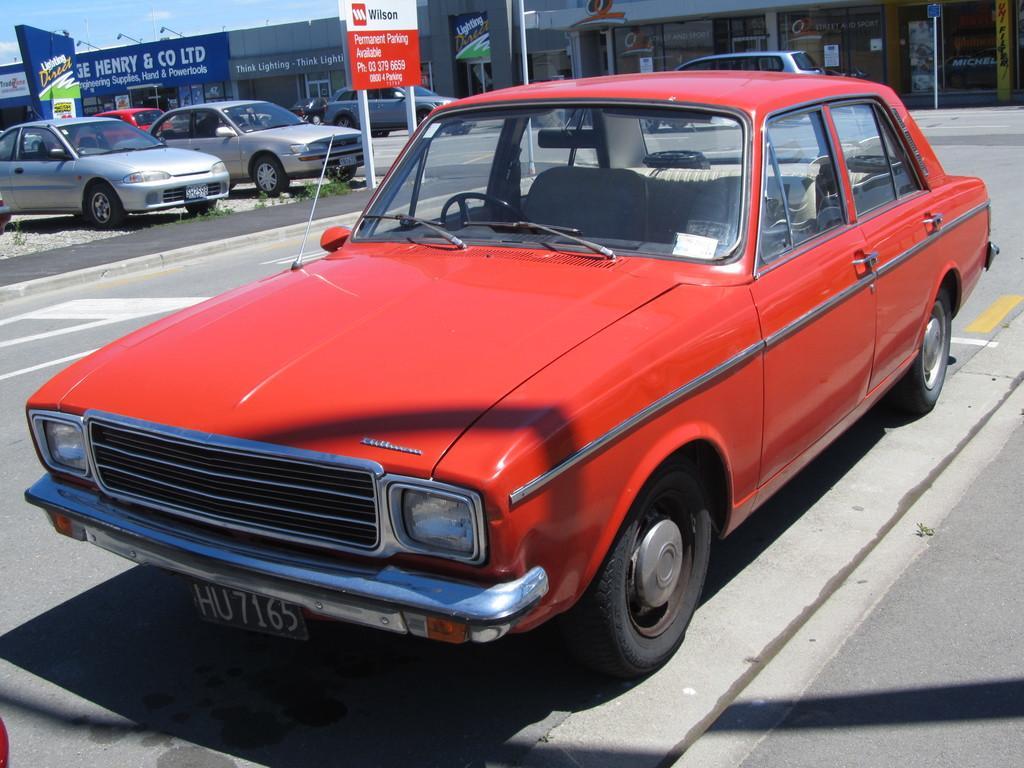In one or two sentences, can you explain what this image depicts? In the image there are few cars parked on the road and behind the cars there are some stores and there are some advertisement boards in between the cars. 